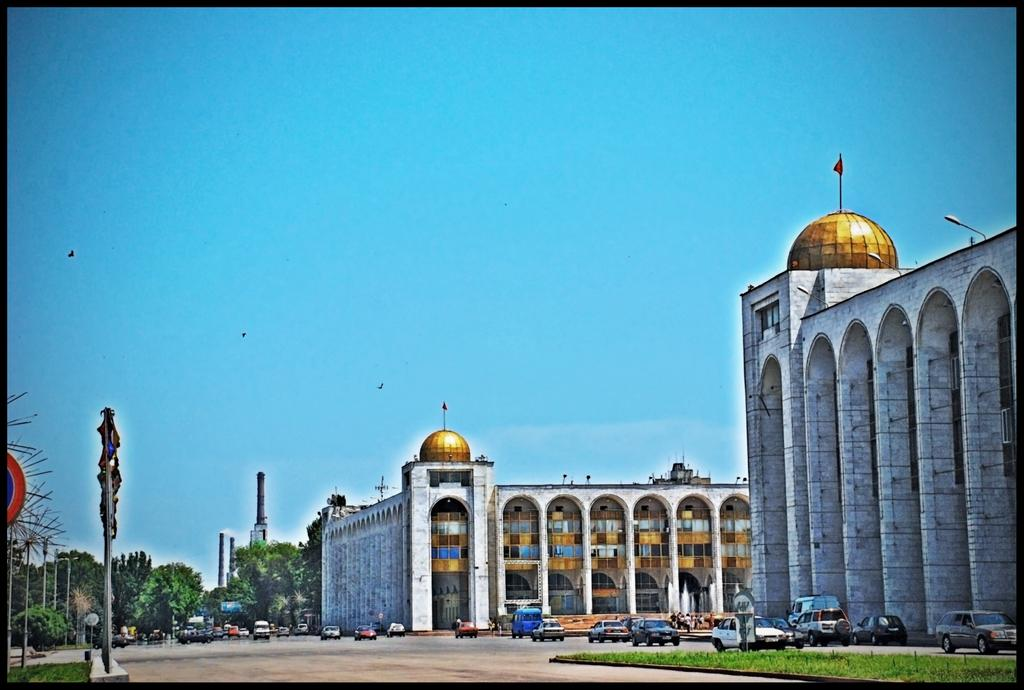What type of structures can be seen in the image? There are buildings in the image. What type of vehicles are on the road in the image? There are cars on the road in the image. What objects are present in the image that are used for supporting or holding things? There are poles in the image. What type of vegetation is located in the bottom left of the image? There are trees in the bottom left of the image. What part of the natural environment is visible in the background of the image? The sky is visible in the background of the image. What type of brush can be seen on the page in the image? There is no brush or page present in the image; it features buildings, cars, poles, trees, and the sky. 